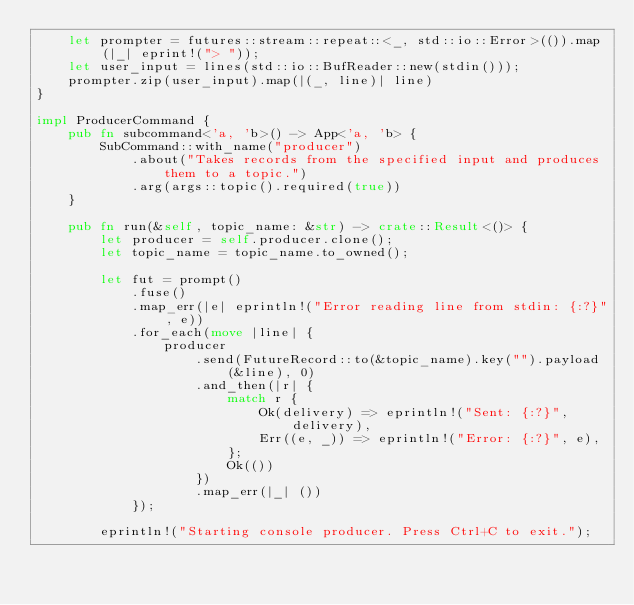<code> <loc_0><loc_0><loc_500><loc_500><_Rust_>    let prompter = futures::stream::repeat::<_, std::io::Error>(()).map(|_| eprint!("> "));
    let user_input = lines(std::io::BufReader::new(stdin()));
    prompter.zip(user_input).map(|(_, line)| line)
}

impl ProducerCommand {
    pub fn subcommand<'a, 'b>() -> App<'a, 'b> {
        SubCommand::with_name("producer")
            .about("Takes records from the specified input and produces them to a topic.")
            .arg(args::topic().required(true))
    }

    pub fn run(&self, topic_name: &str) -> crate::Result<()> {
        let producer = self.producer.clone();
        let topic_name = topic_name.to_owned();

        let fut = prompt()
            .fuse()
            .map_err(|e| eprintln!("Error reading line from stdin: {:?}", e))
            .for_each(move |line| {
                producer
                    .send(FutureRecord::to(&topic_name).key("").payload(&line), 0)
                    .and_then(|r| {
                        match r {
                            Ok(delivery) => eprintln!("Sent: {:?}", delivery),
                            Err((e, _)) => eprintln!("Error: {:?}", e),
                        };
                        Ok(())
                    })
                    .map_err(|_| ())
            });

        eprintln!("Starting console producer. Press Ctrl+C to exit.");</code> 